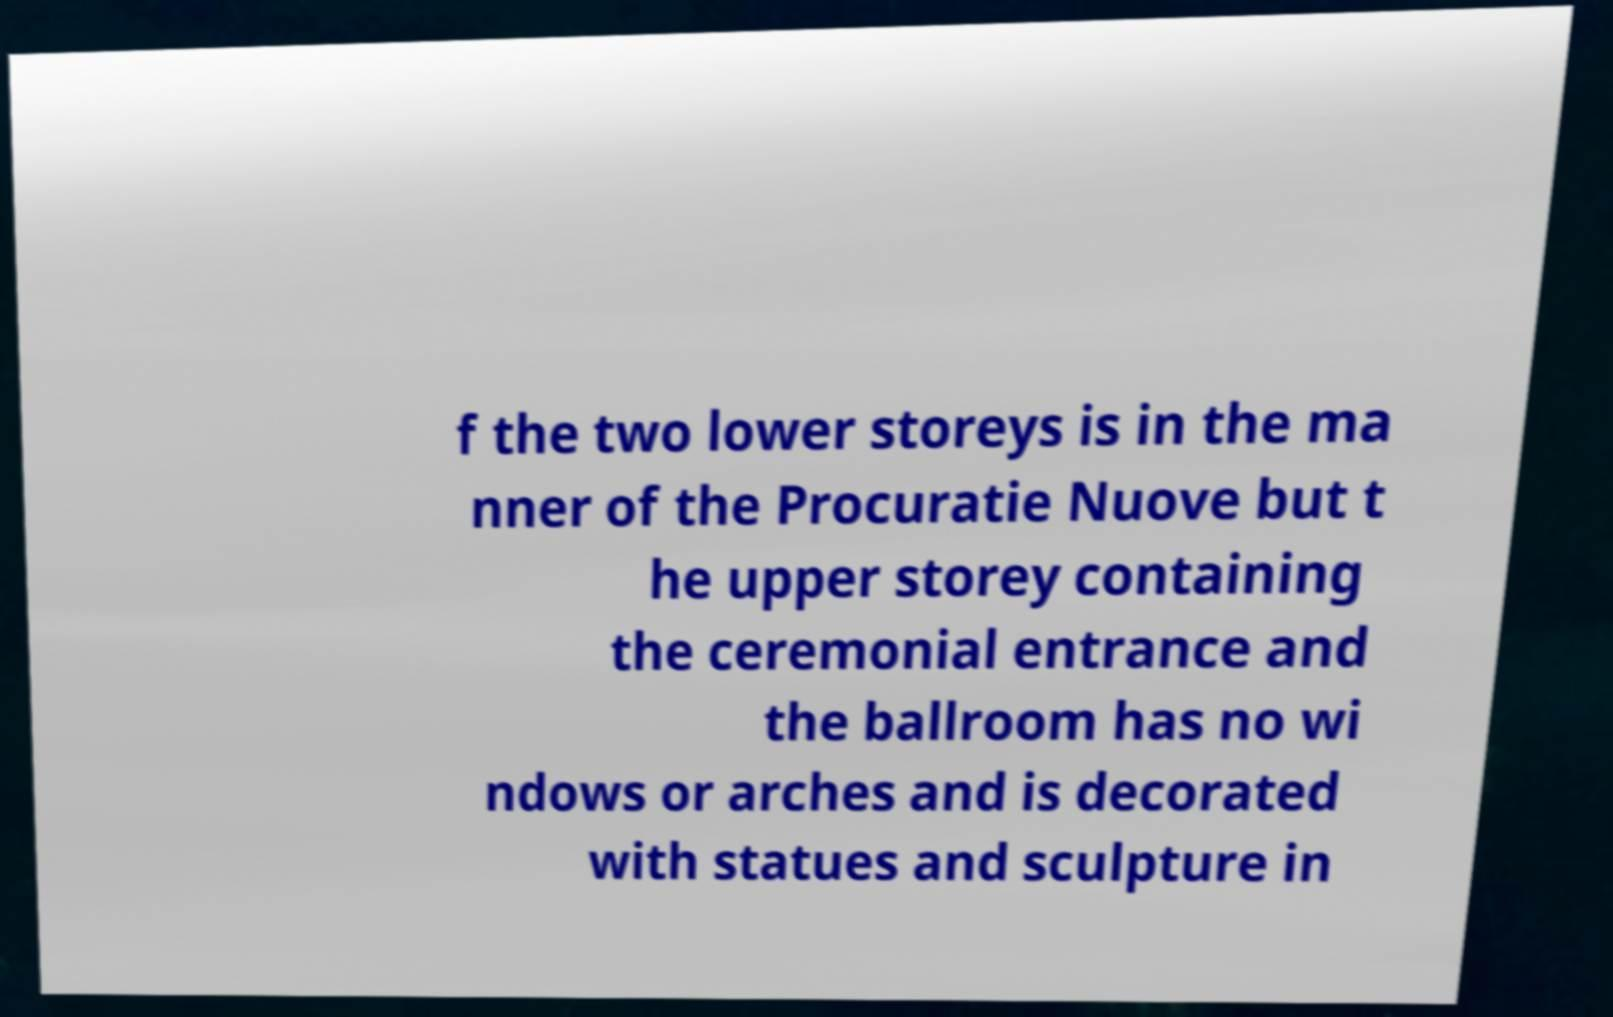Could you extract and type out the text from this image? f the two lower storeys is in the ma nner of the Procuratie Nuove but t he upper storey containing the ceremonial entrance and the ballroom has no wi ndows or arches and is decorated with statues and sculpture in 